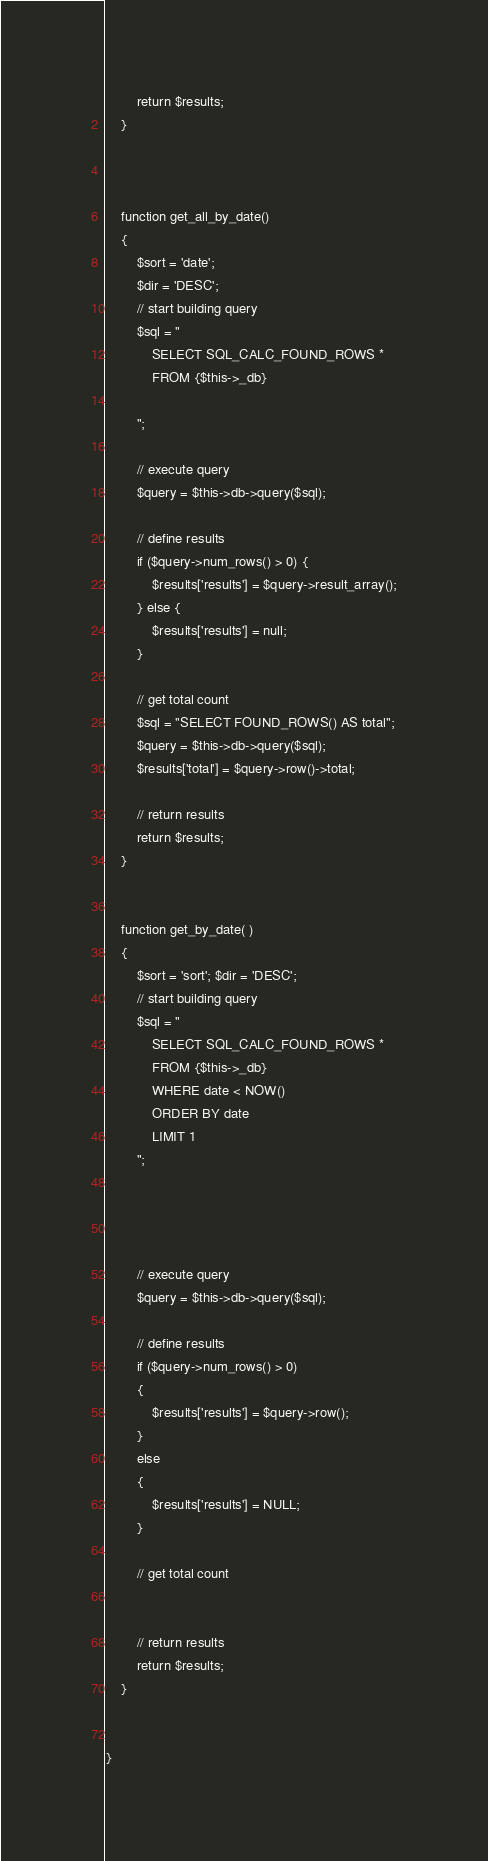Convert code to text. <code><loc_0><loc_0><loc_500><loc_500><_PHP_>        return $results;
    }

    

    function get_all_by_date()
    {
        $sort = 'date';
        $dir = 'DESC';
        // start building query
        $sql = "
            SELECT SQL_CALC_FOUND_ROWS *
            FROM {$this->_db}
           
        ";

        // execute query
        $query = $this->db->query($sql);

        // define results
        if ($query->num_rows() > 0) {
            $results['results'] = $query->result_array();
        } else {
            $results['results'] = null;
        }

        // get total count
        $sql = "SELECT FOUND_ROWS() AS total";
        $query = $this->db->query($sql);
        $results['total'] = $query->row()->total;

        // return results
        return $results;
    }


    function get_by_date( )
    {
        $sort = 'sort'; $dir = 'DESC';
        // start building query
        $sql = "
            SELECT SQL_CALC_FOUND_ROWS *
            FROM {$this->_db}
            WHERE date < NOW()
            ORDER BY date
            LIMIT 1
        ";

       

   
        // execute query
        $query = $this->db->query($sql);

        // define results
        if ($query->num_rows() > 0)
        {
            $results['results'] = $query->row();
        }
        else
        {
            $results['results'] = NULL;
        }

        // get total count
     

        // return results
        return $results;
    }


}
</code> 